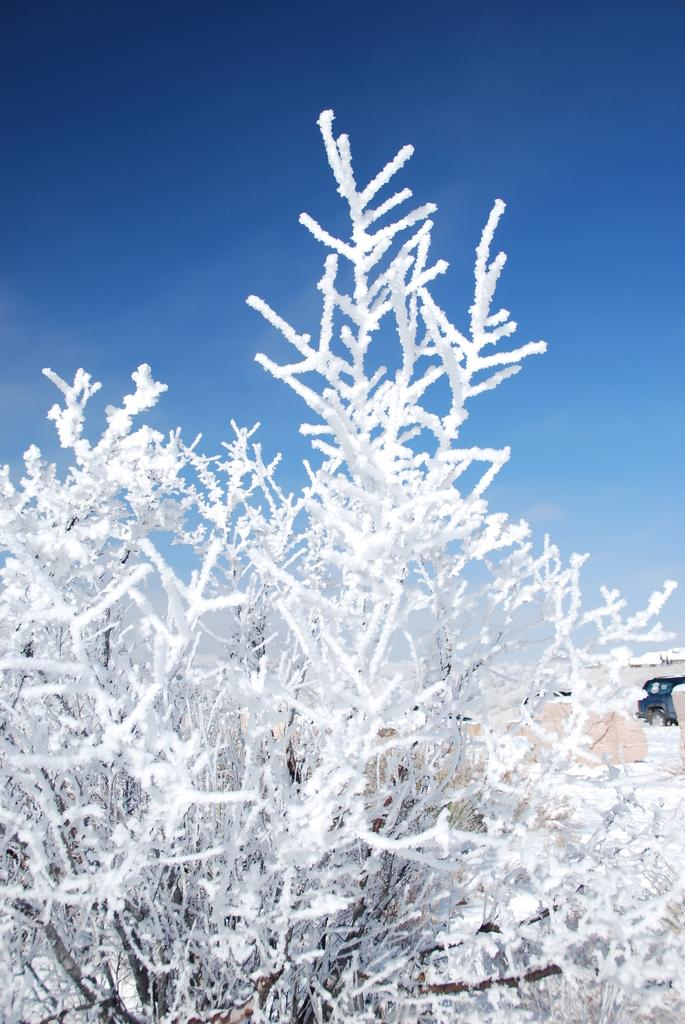What is present in the image that is not a part of the natural environment? There is a car in the background of the image. What type of plant is visible in the image? The plant in the image is covered in snow. What can be seen in the sky in the image? The sky is visible in the image, and its color is blue. How many letters are visible on the chair in the image? There is no chair present in the image, so it is not possible to determine how many letters might be visible on it. 